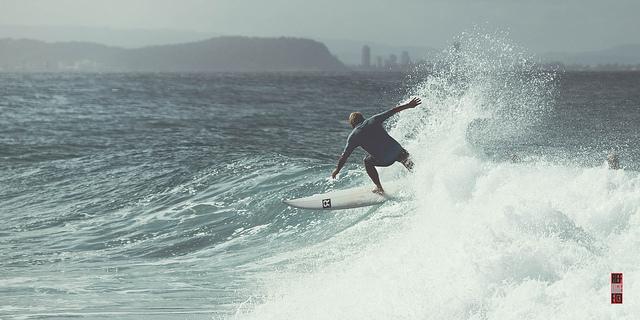Is it a cloudy day?
Be succinct. Yes. Is the man a pro?
Short answer required. Yes. What is written on the man's back?
Keep it brief. Nothing. Is the man falling backwards or forwards?
Be succinct. Forwards. Is the water cold?
Answer briefly. Yes. 